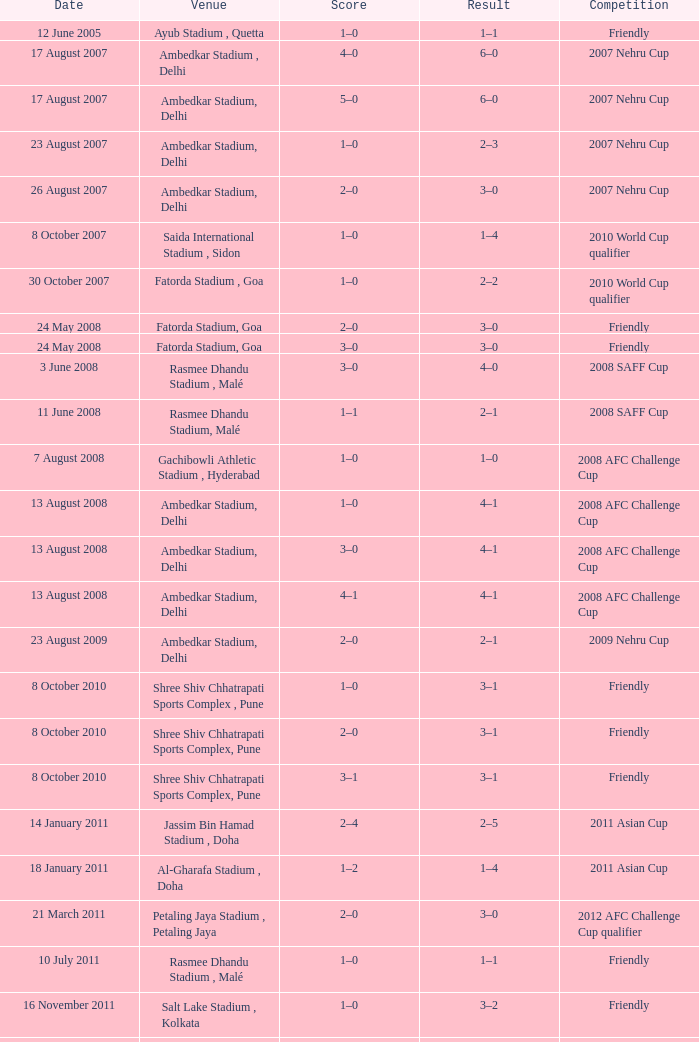On august 22, 2012, what was the score? 1–0. 